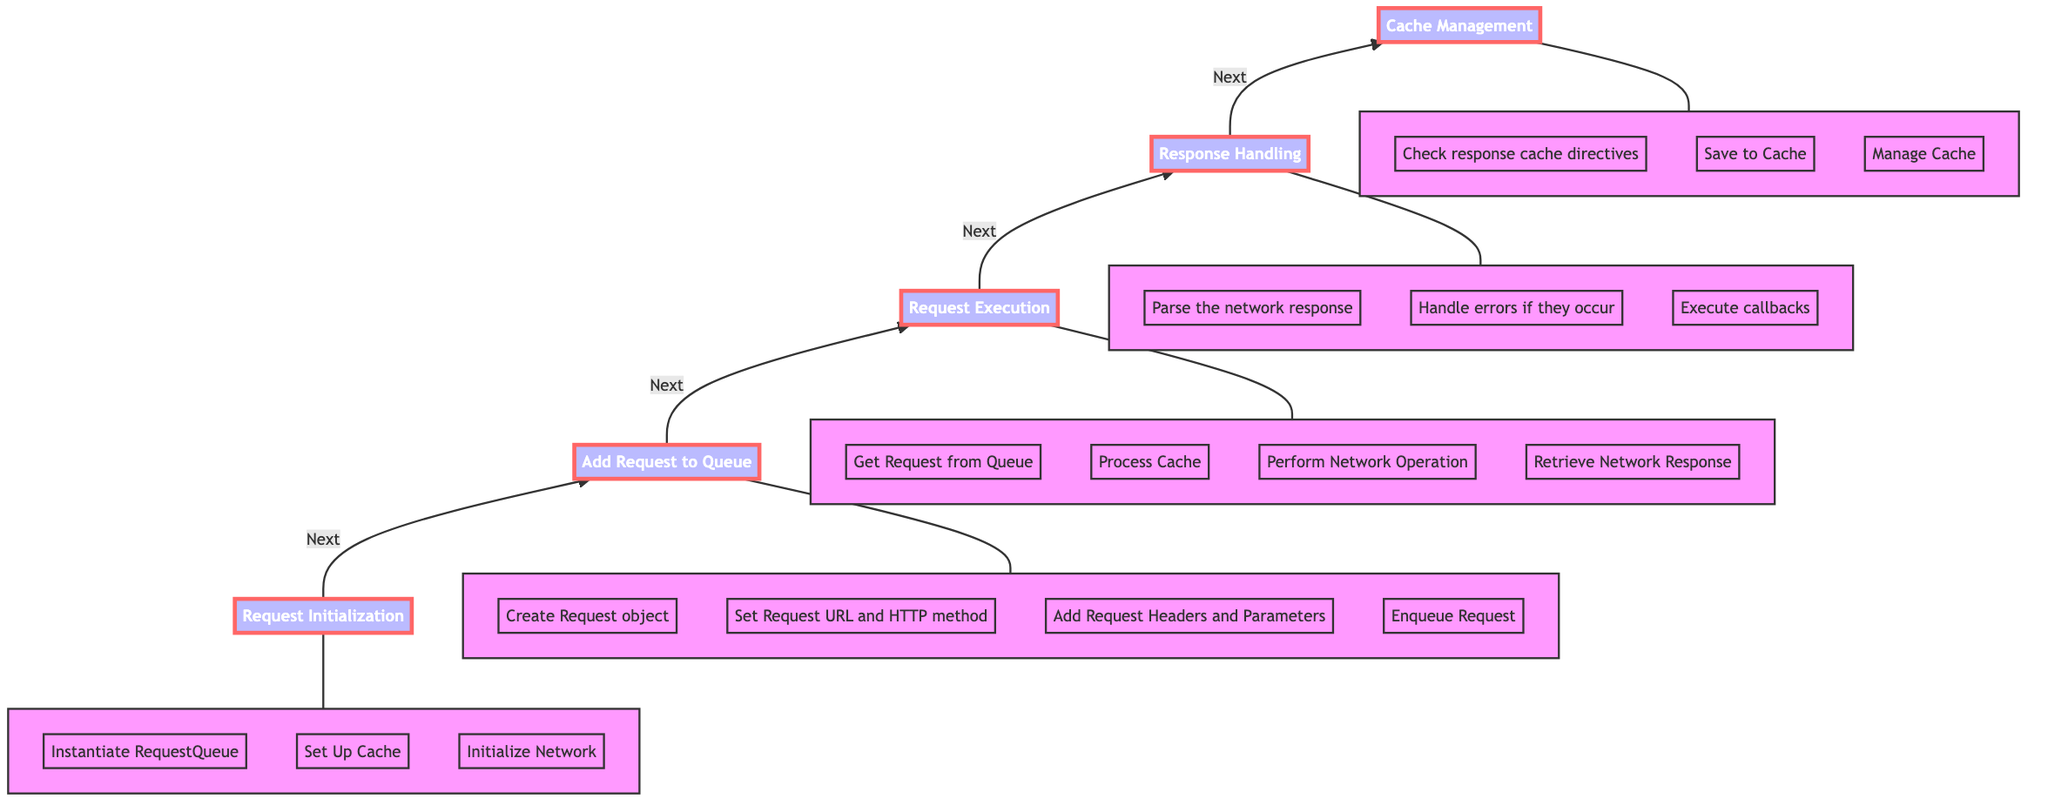What is the first stage in the handling of network requests? The first stage in the diagram is Request Initialization, which is marked at the bottom of the flow chart indicating it begins the process.
Answer: Request Initialization How many stages are present in the flow chart? The flow chart contains five distinct stages: Request Initialization, Add Request to Queue, Request Execution, Response Handling, and Cache Management.
Answer: Five What stage comes after Request Execution? Following Request Execution, the next stage in the flow chart is Response Handling, as indicated by the arrow pointing up to the next node.
Answer: Response Handling Which action is the final step in the process? The last action detailed in the flow chart is related to Cache Management, specifically managing cache, which concludes the handling of network requests.
Answer: Manage Cache What is one task done during Request Initialization? One specific task during Request Initialization is to instantiate the RequestQueue, setting up the foundation for managing requests accordingly.
Answer: Instantiate RequestQueue In which stage do you parse the network response? The parsing of the network response occurs during the Response Handling stage, where the response is processed following the network operation.
Answer: Response Handling How is a request added to the RequestQueue? A request is added to the RequestQueue by using the add(request) method, which is specified in the Add Request to Queue stage.
Answer: Add Request What is performed immediately after adding a request to the queue? After adding a request to the queue, the next action taken is the execution of the request, which signifies it is ready to be processed.
Answer: Request Execution Which aspect involves checking cache directives? The aspect of checking response cache directives is part of Cache Management, ensuring that appropriate caching is conducted based on network responses.
Answer: Check response cache directives 